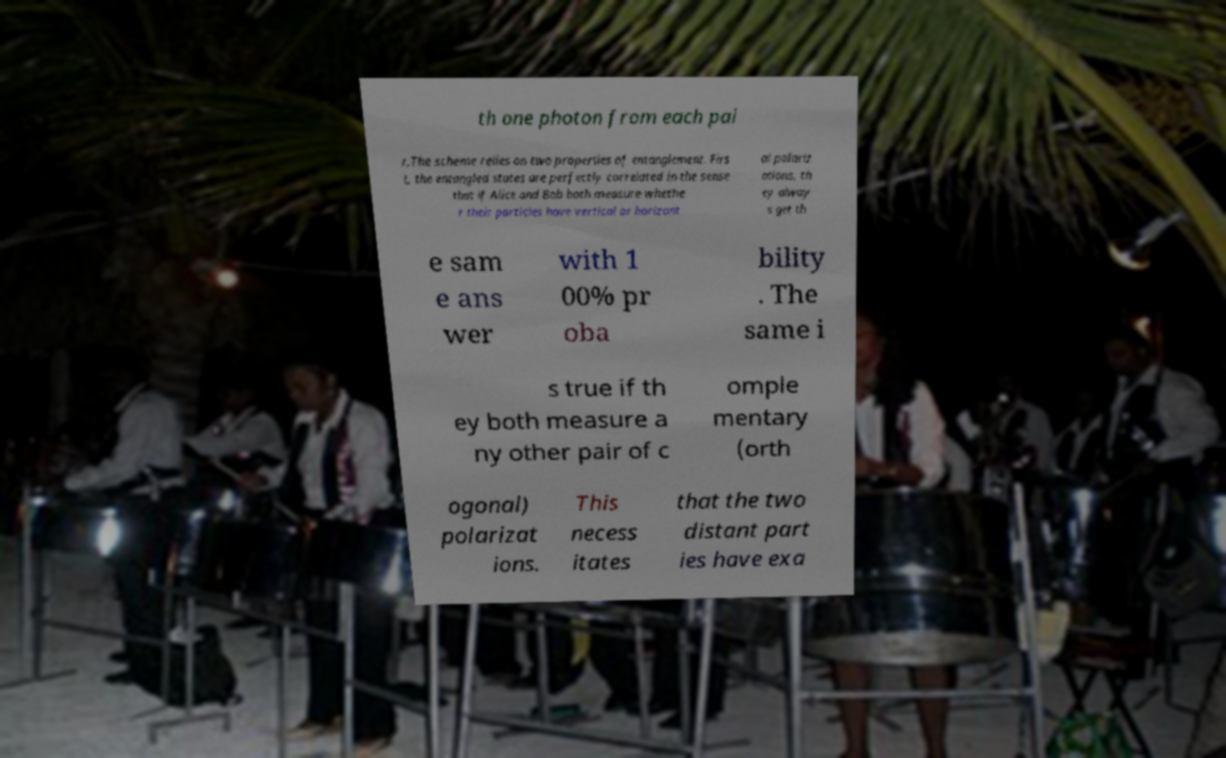What messages or text are displayed in this image? I need them in a readable, typed format. th one photon from each pai r.The scheme relies on two properties of entanglement. Firs t, the entangled states are perfectly correlated in the sense that if Alice and Bob both measure whethe r their particles have vertical or horizont al polariz ations, th ey alway s get th e sam e ans wer with 1 00% pr oba bility . The same i s true if th ey both measure a ny other pair of c omple mentary (orth ogonal) polarizat ions. This necess itates that the two distant part ies have exa 